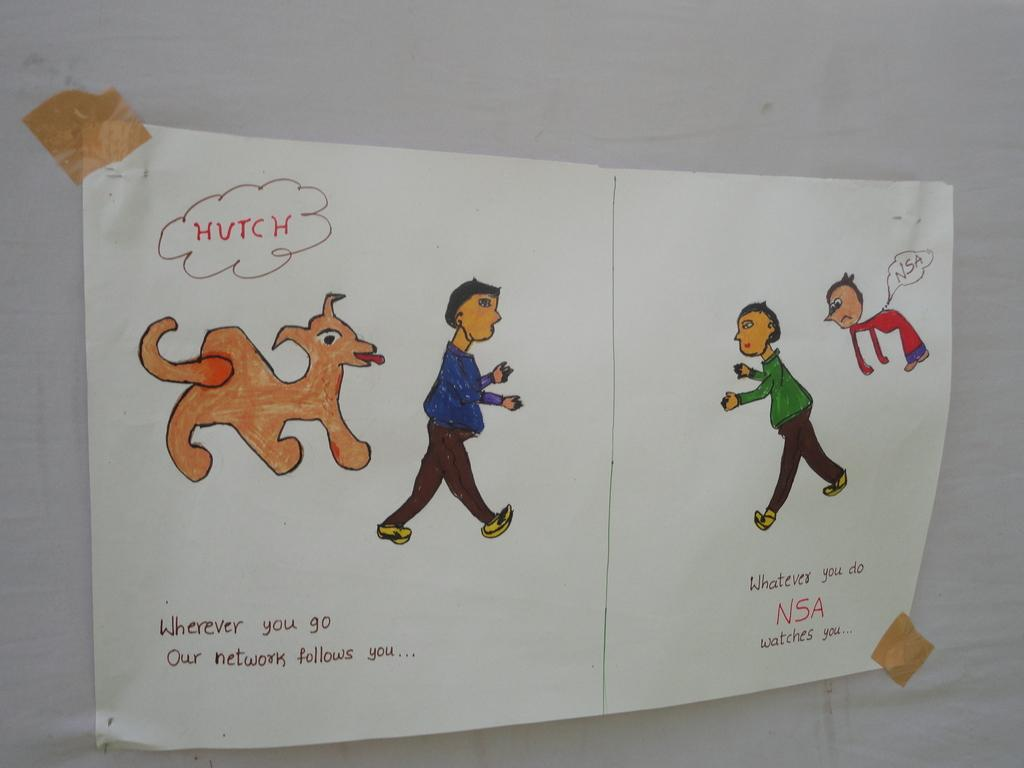What is present on the paper in the image? The paper has a drawing of people on it. Can you describe the drawing on the paper? The drawing includes a dog. Is there any text on the paper? Yes, there is text on the paper. What type of cart is being used to transport the balls in the image? There are no carts or balls present in the image; it only features a paper with a drawing of people and a dog, along with some text. 